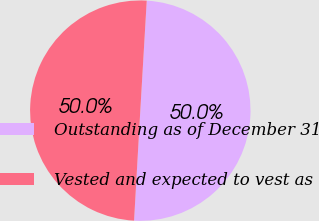<chart> <loc_0><loc_0><loc_500><loc_500><pie_chart><fcel>Outstanding as of December 31<fcel>Vested and expected to vest as<nl><fcel>49.97%<fcel>50.03%<nl></chart> 